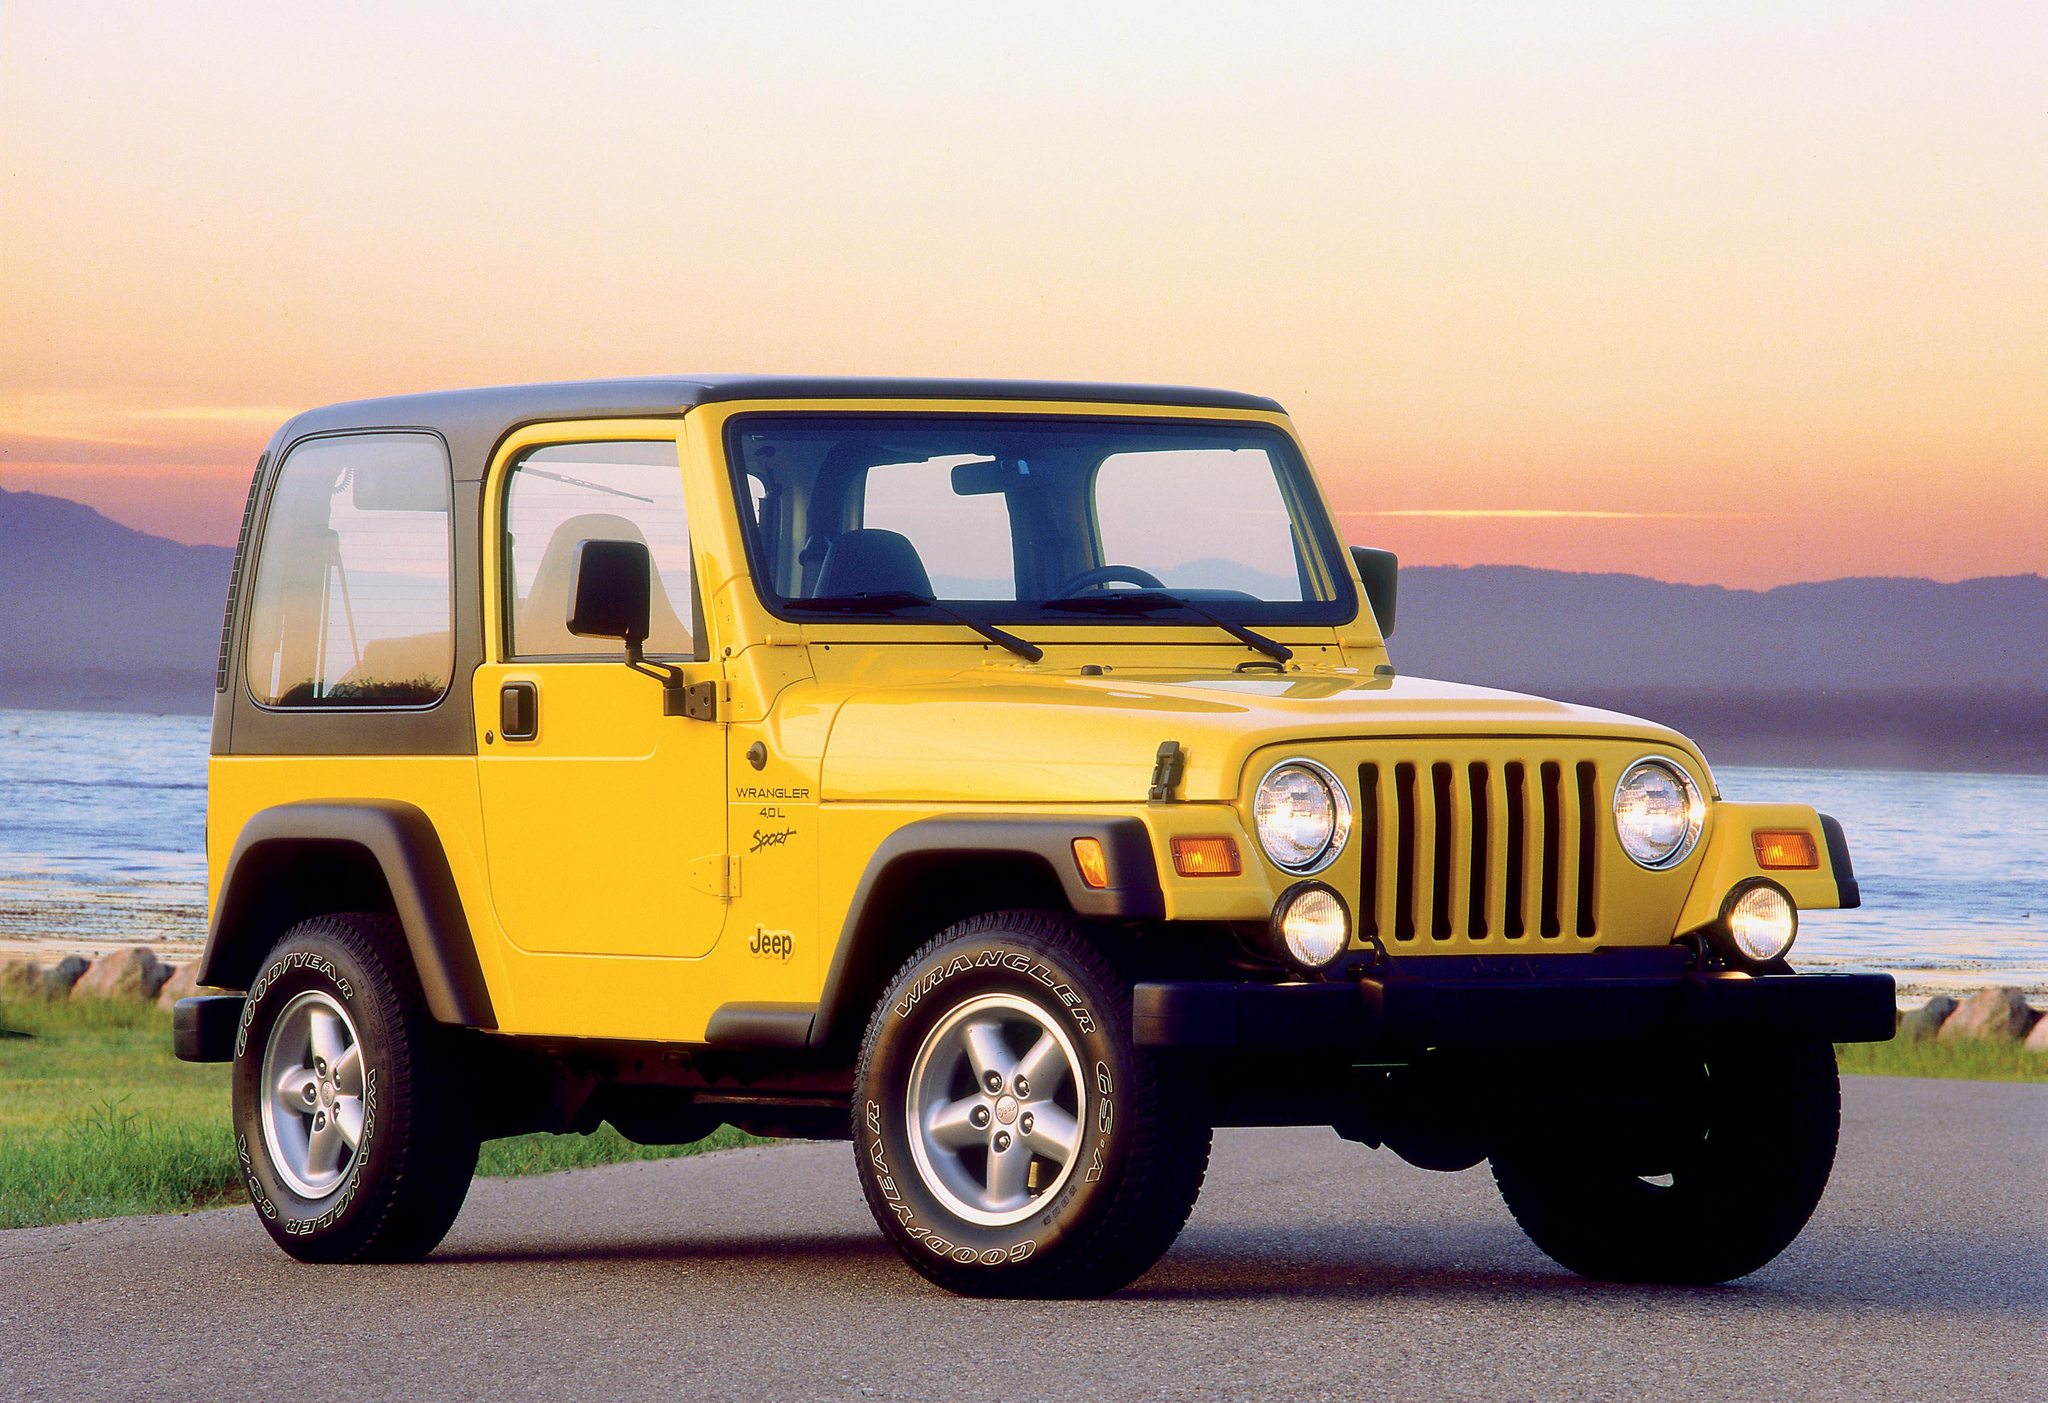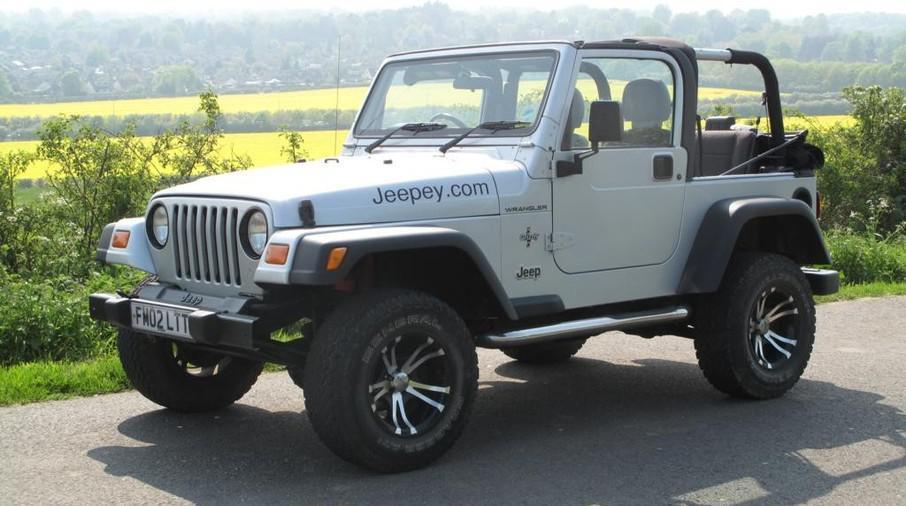The first image is the image on the left, the second image is the image on the right. Considering the images on both sides, is "there are two jeeps in the image pair facing each other" valid? Answer yes or no. Yes. The first image is the image on the left, the second image is the image on the right. Given the left and right images, does the statement "Both vehicles are Jeep Wranglers." hold true? Answer yes or no. Yes. 